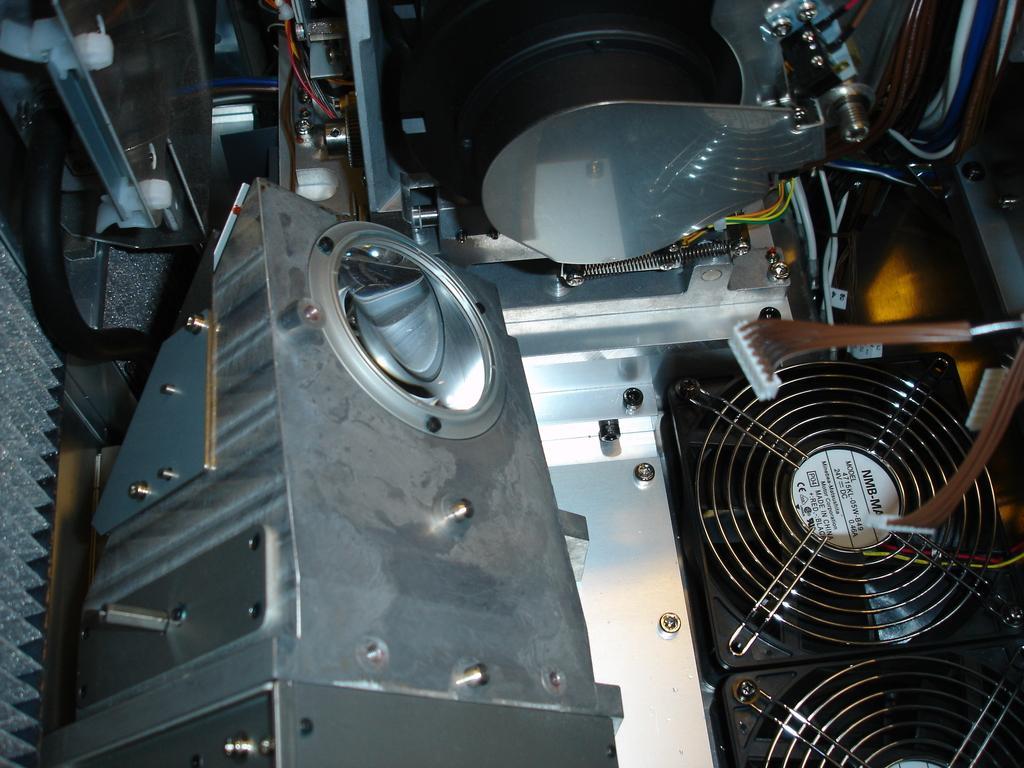In one or two sentences, can you explain what this image depicts? In this image, we can see an electronic machine. 